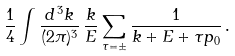Convert formula to latex. <formula><loc_0><loc_0><loc_500><loc_500>\frac { 1 } { 4 } \int \frac { d ^ { \, 3 } k } { ( 2 \pi ) ^ { 3 } } \, \frac { k } { E } \sum _ { \tau = \pm } \frac { 1 } { k + E + \tau p _ { 0 } } \, .</formula> 